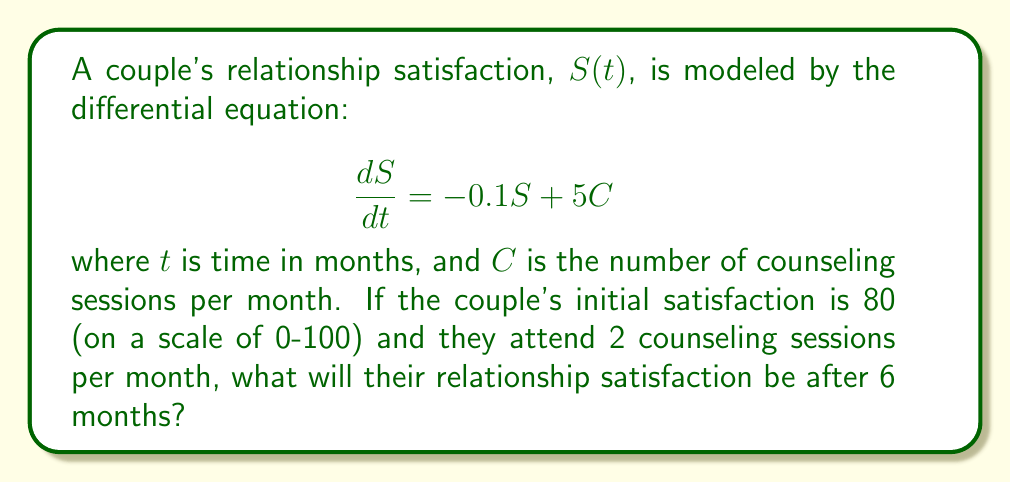Help me with this question. To solve this problem, we need to use the general solution for first-order linear differential equations:

1) The general form is $\frac{dy}{dx} + P(x)y = Q(x)$, where in our case:
   $y = S$, $x = t$, $P(t) = 0.1$, and $Q(t) = 5C = 10$

2) The general solution is $y = e^{-\int P(x)dx}(\int Q(x)e^{\int P(x)dx}dx + C)$

3) Solving for our equation:
   $S(t) = e^{-0.1t}(\int 10e^{0.1t}dt + C)$
   
4) Integrating:
   $S(t) = e^{-0.1t}(100e^{0.1t} + C)$
   $S(t) = 100 + Ce^{-0.1t}$

5) Using the initial condition $S(0) = 80$:
   $80 = 100 + C$
   $C = -20$

6) Therefore, the particular solution is:
   $S(t) = 100 - 20e^{-0.1t}$

7) To find $S(6)$, we substitute $t = 6$:
   $S(6) = 100 - 20e^{-0.1(6)}$
   $S(6) = 100 - 20e^{-0.6}$
   $S(6) \approx 89.0$
Answer: 89.0 